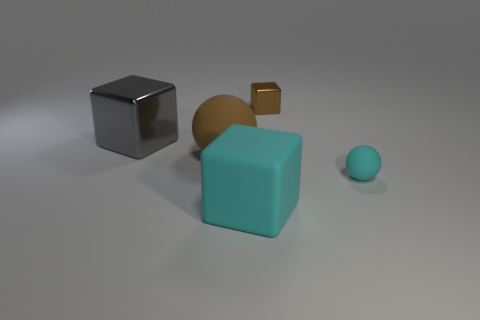Add 5 large cyan matte cubes. How many objects exist? 10 Subtract all spheres. How many objects are left? 3 Add 4 large cyan matte cubes. How many large cyan matte cubes are left? 5 Add 4 balls. How many balls exist? 6 Subtract 0 yellow cylinders. How many objects are left? 5 Subtract all big things. Subtract all cyan cubes. How many objects are left? 1 